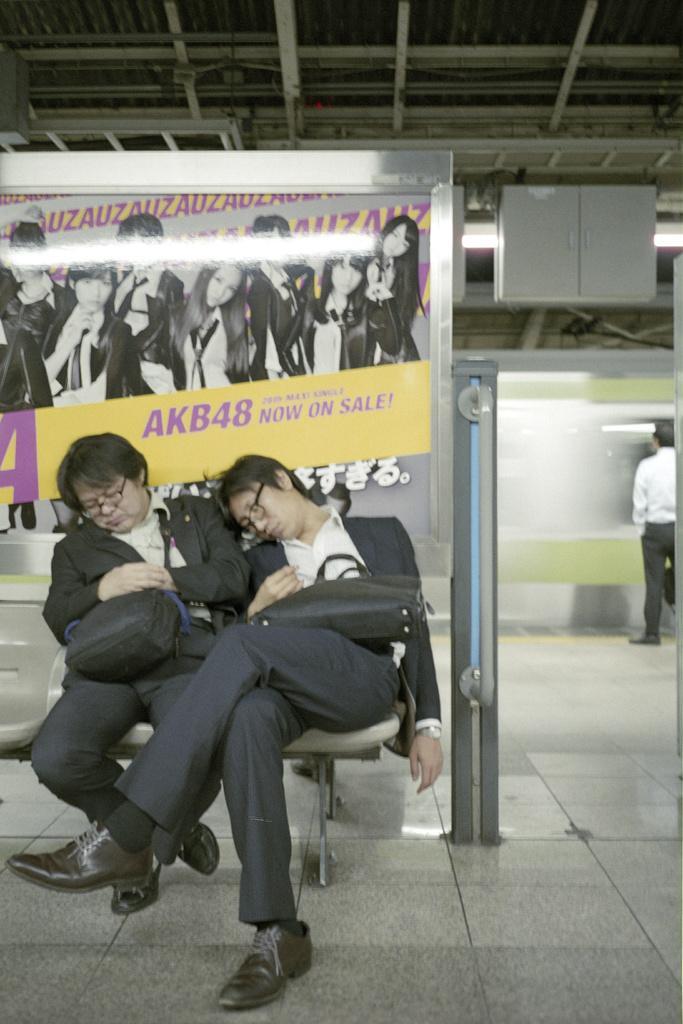How would you summarize this image in a sentence or two? In this image I can see two people with blazers, shirts and pant and these people are sitting on the chairs. I can see these people with the bags. To the right I can see the person standing. In the background I can see the board and there is a cabinet to the roof. 